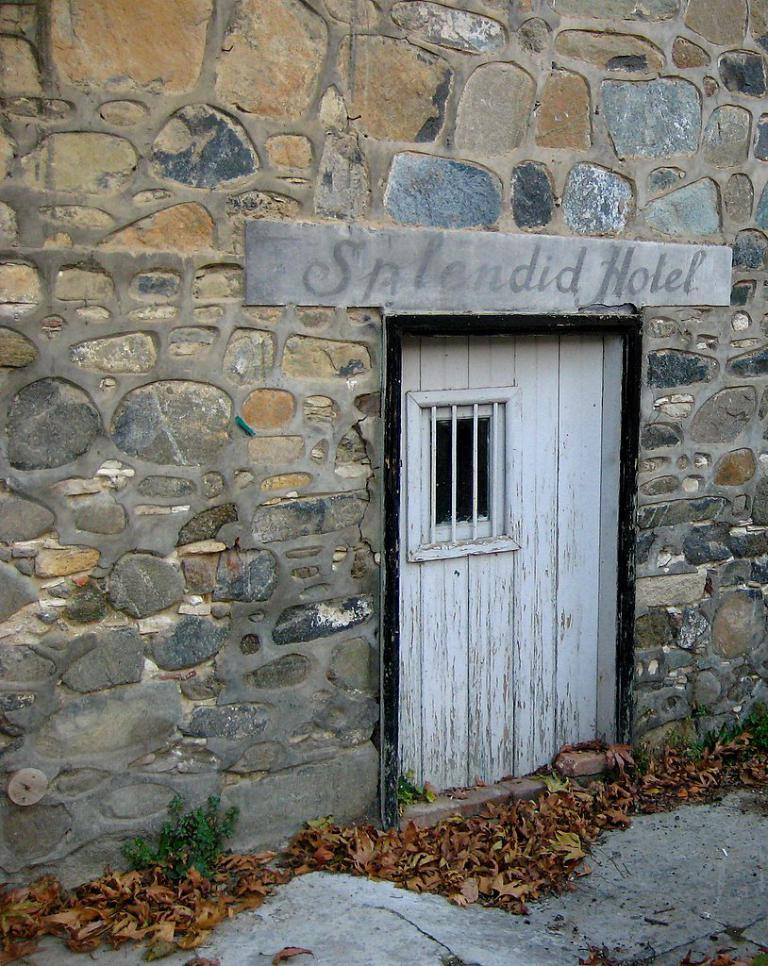What type of structure is shown in the image? The image depicts a building. What can be seen on the wall inside the building? There is a board with text on the wall. How can one enter the building? There is a door visible in the image. What is present on the ground outside the building? Leaves are present on the ground. What type of cloth is draped over the door in the image? There is no cloth draped over the door in the image; only the door itself is visible. 